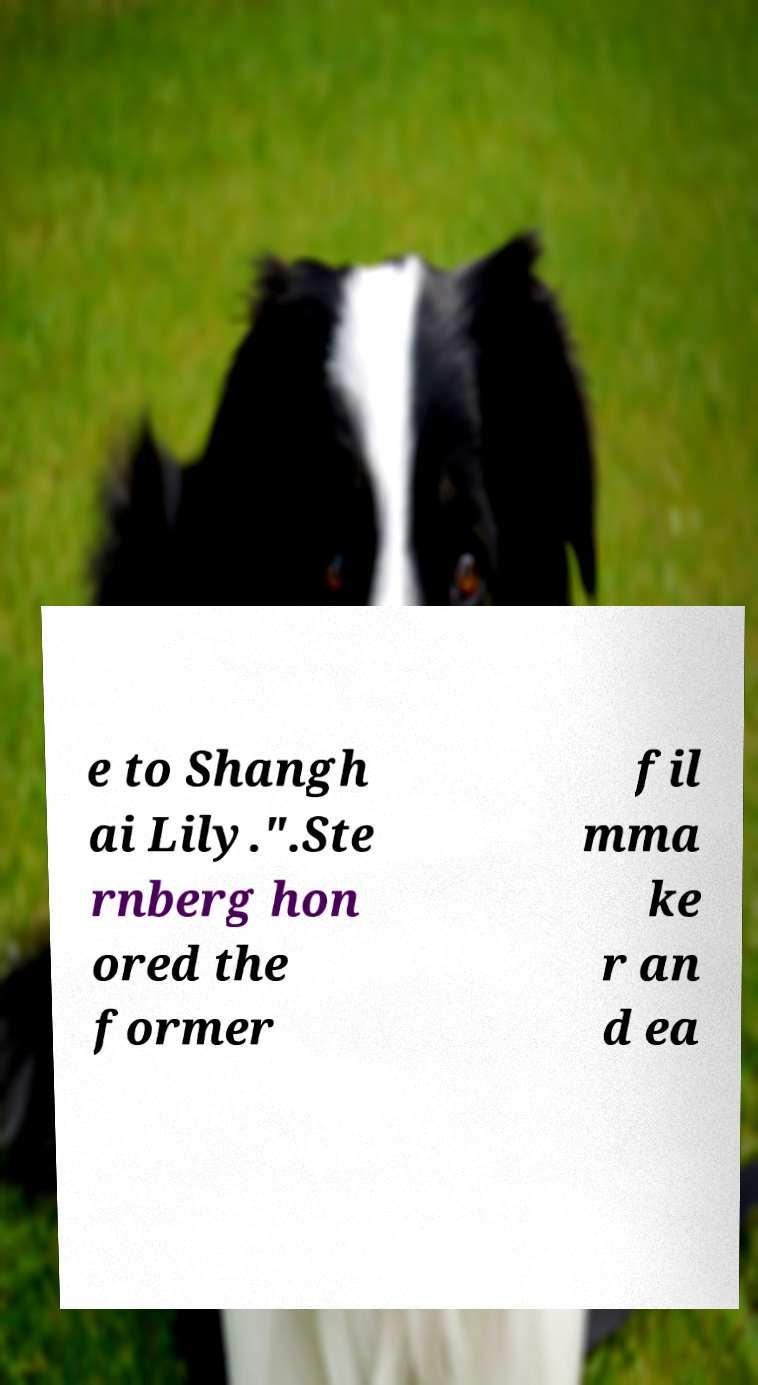Please identify and transcribe the text found in this image. e to Shangh ai Lily.".Ste rnberg hon ored the former fil mma ke r an d ea 